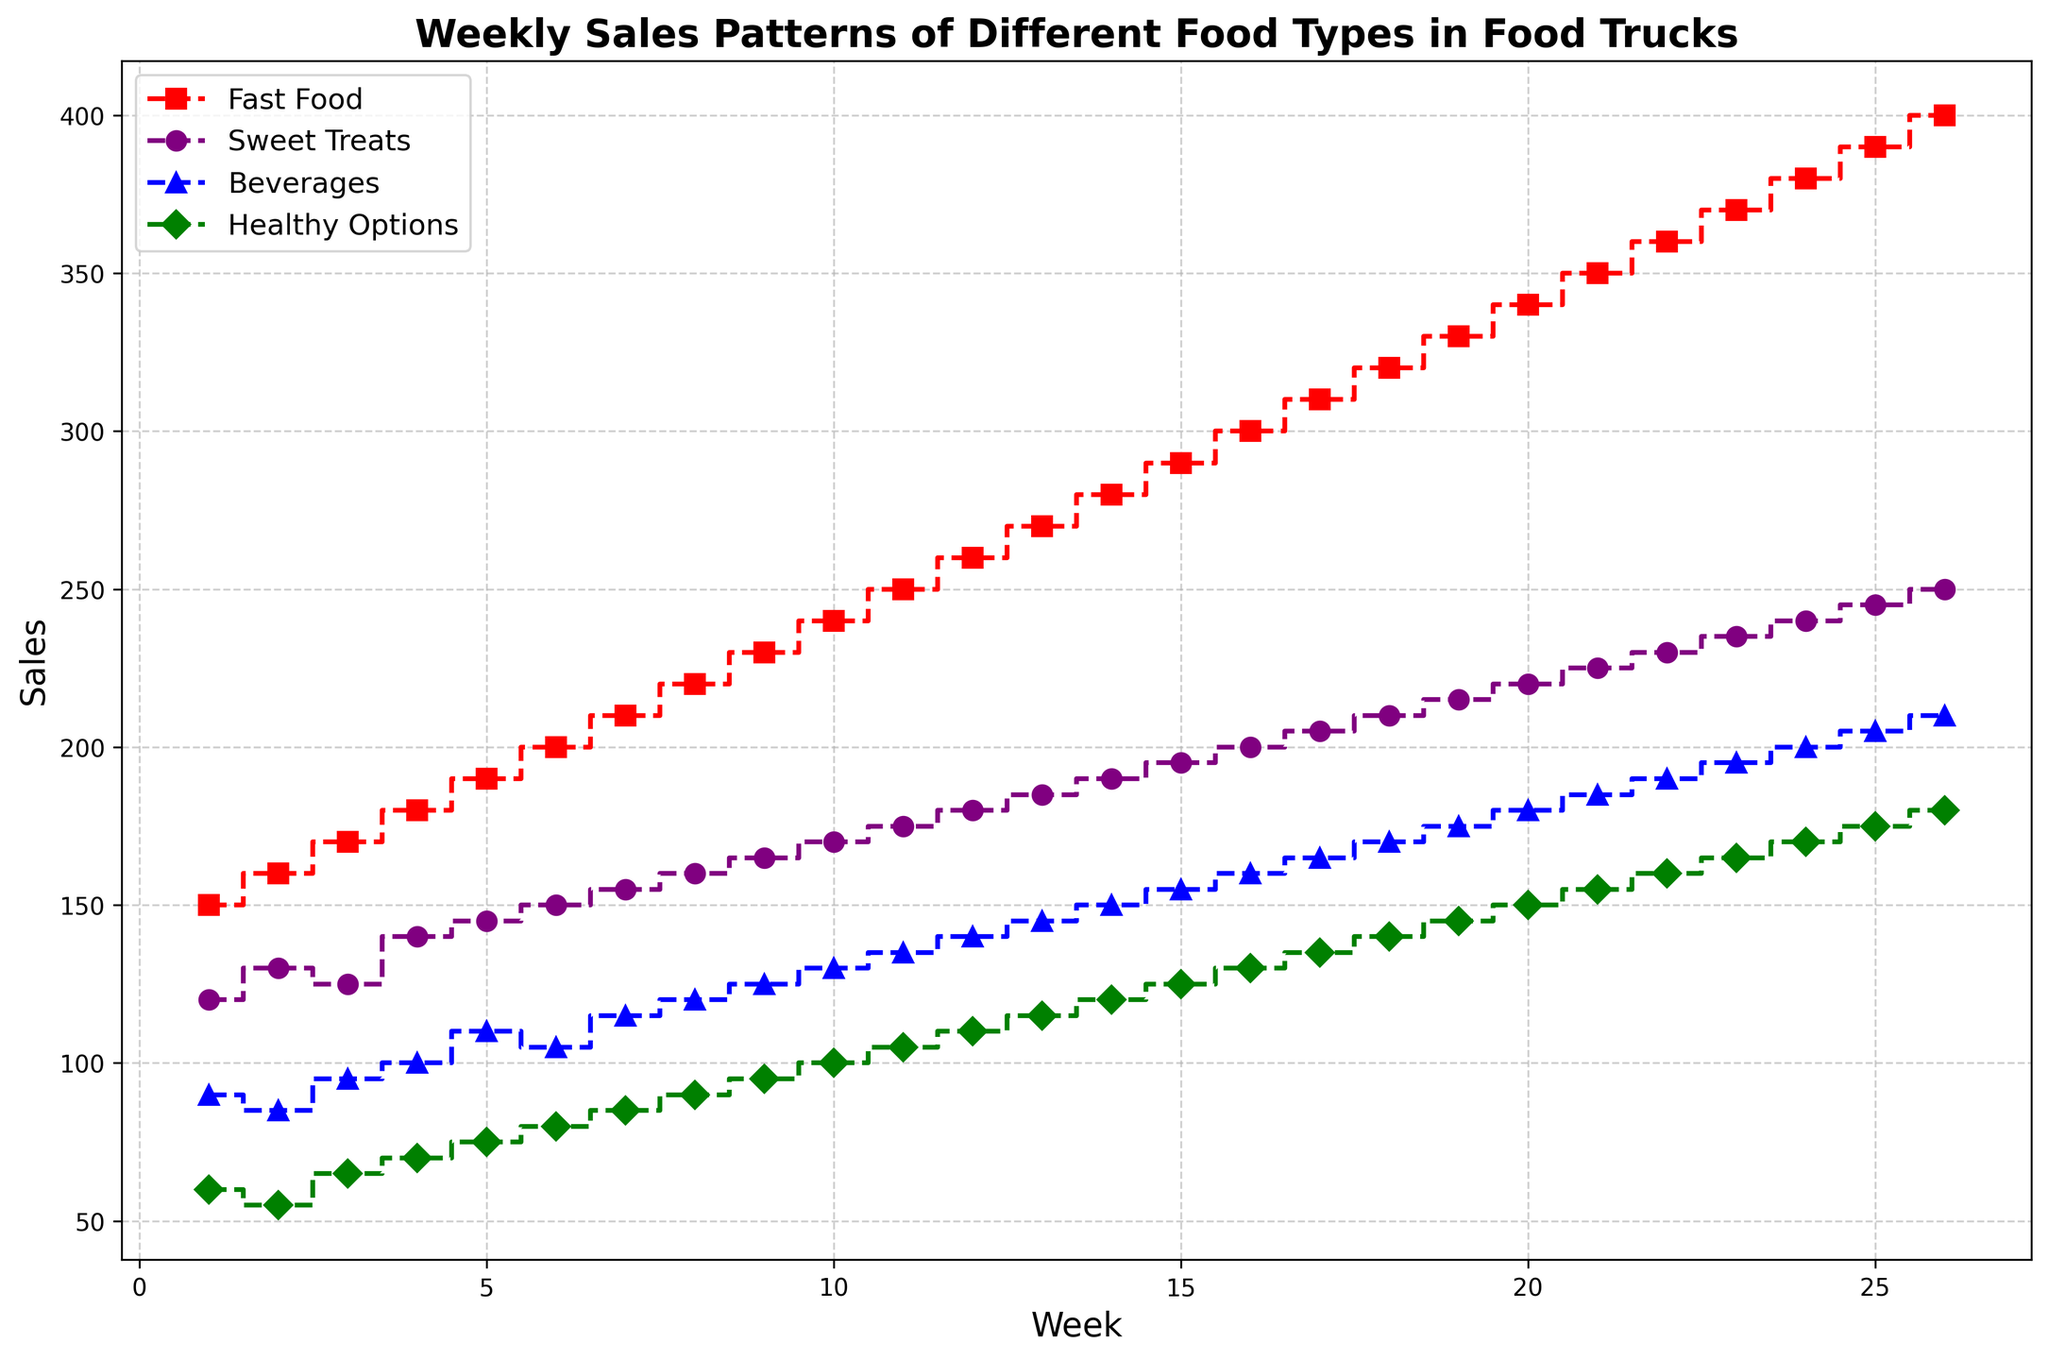Which food type shows the highest sales at Week 10? According to the chart, the Fast Food line (red) reaches the highest sales at Week 10 compared to other food types.
Answer: Fast Food What's the difference in sales between Sweet Treats and Healthy Options at Week 15? At Week 15, Sweet Treats sales are 195, while Healthy Options are 125. The difference is calculated as 195 - 125 = 70.
Answer: 70 Are Beverages sales ever higher than Sweet Treats sales across all weeks? Observing the chart, the line representing Beverages (blue) is consistently below the Sweet Treats (purple) line in every week. Thus, Beverages sales are never higher than Sweet Treats.
Answer: No What is the average sales of Fast Food over the first five weeks? Sum up the Fast Food sales for Weeks 1-5: 150 + 160 + 170 + 180 + 190 = 850. The average is computed as 850 / 5 = 170.
Answer: 170 By how much did Healthy Options sales increase from Week 1 to Week 26? Healthy Options sales were 60 in Week 1 and increased to 180 by Week 26. The increase is calculated as 180 - 60 = 120.
Answer: 120 Compare the increase in sales of Fast Food and Beverages between Week 10 and Week 20. Fast Food sales increased from 240 to 340 (an increase of 100), while Beverages sales increased from 130 to 180 (an increase of 50) between Week 10 and Week 20.
Answer: Fast Food increased more What is the average weekly sales of Beverages over the entire period? Sum up the Beverages sales from Week 1 to 26: 90 + 85 + 95 + 100 + 110 + 105 + 115 + 120 + 125 + 130 + 135 + 140 + 145 + 150 + 155 + 160 + 165 + 170 + 175 + 180 + 185 + 190 + 195 + 200 + 205 + 210 = 3840. The average is 3840 / 26 ≈ 147.7.
Answer: 147.7 